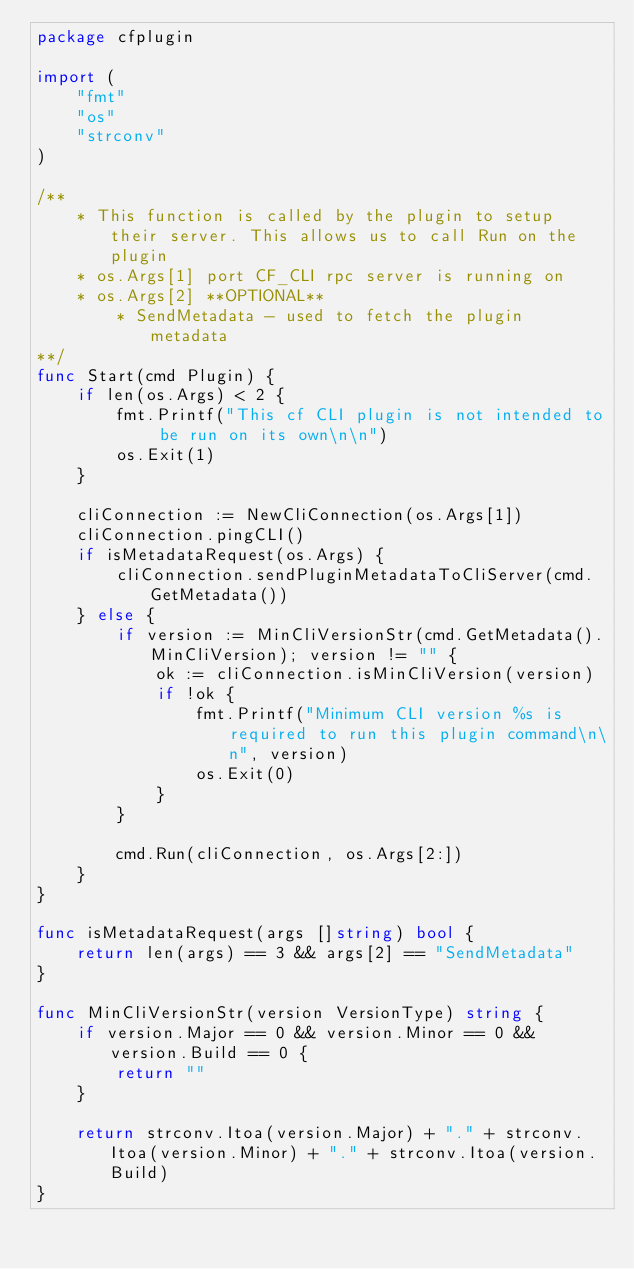<code> <loc_0><loc_0><loc_500><loc_500><_Go_>package cfplugin

import (
	"fmt"
	"os"
	"strconv"
)

/**
	* This function is called by the plugin to setup their server. This allows us to call Run on the plugin
	* os.Args[1] port CF_CLI rpc server is running on
	* os.Args[2] **OPTIONAL**
		* SendMetadata - used to fetch the plugin metadata
**/
func Start(cmd Plugin) {
	if len(os.Args) < 2 {
		fmt.Printf("This cf CLI plugin is not intended to be run on its own\n\n")
		os.Exit(1)
	}

	cliConnection := NewCliConnection(os.Args[1])
	cliConnection.pingCLI()
	if isMetadataRequest(os.Args) {
		cliConnection.sendPluginMetadataToCliServer(cmd.GetMetadata())
	} else {
		if version := MinCliVersionStr(cmd.GetMetadata().MinCliVersion); version != "" {
			ok := cliConnection.isMinCliVersion(version)
			if !ok {
				fmt.Printf("Minimum CLI version %s is required to run this plugin command\n\n", version)
				os.Exit(0)
			}
		}

		cmd.Run(cliConnection, os.Args[2:])
	}
}

func isMetadataRequest(args []string) bool {
	return len(args) == 3 && args[2] == "SendMetadata"
}

func MinCliVersionStr(version VersionType) string {
	if version.Major == 0 && version.Minor == 0 && version.Build == 0 {
		return ""
	}

	return strconv.Itoa(version.Major) + "." + strconv.Itoa(version.Minor) + "." + strconv.Itoa(version.Build)
}
</code> 